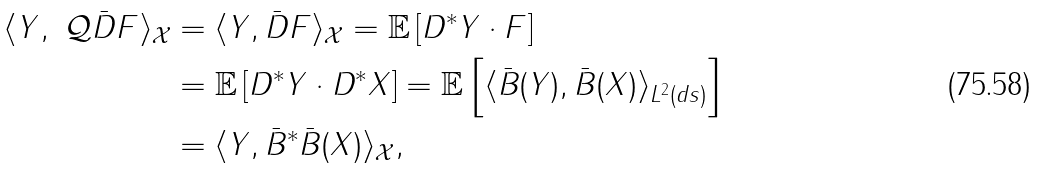<formula> <loc_0><loc_0><loc_500><loc_500>\langle Y , \mathcal { \ Q } \bar { D } F \rangle _ { \mathcal { X } } & = \langle Y , \bar { D } F \rangle _ { \mathcal { X } } = \mathbb { E } \left [ D ^ { \ast } Y \cdot F \right ] \\ & = \mathbb { E } \left [ D ^ { \ast } Y \cdot D ^ { \ast } X \right ] = \mathbb { E } \left [ \langle \bar { B } ( Y ) , \bar { B } ( X ) \rangle _ { L ^ { 2 } ( d s ) } \right ] \\ & = \langle Y , \bar { B } ^ { \ast } \bar { B } ( X ) \rangle _ { \mathcal { X } } ,</formula> 